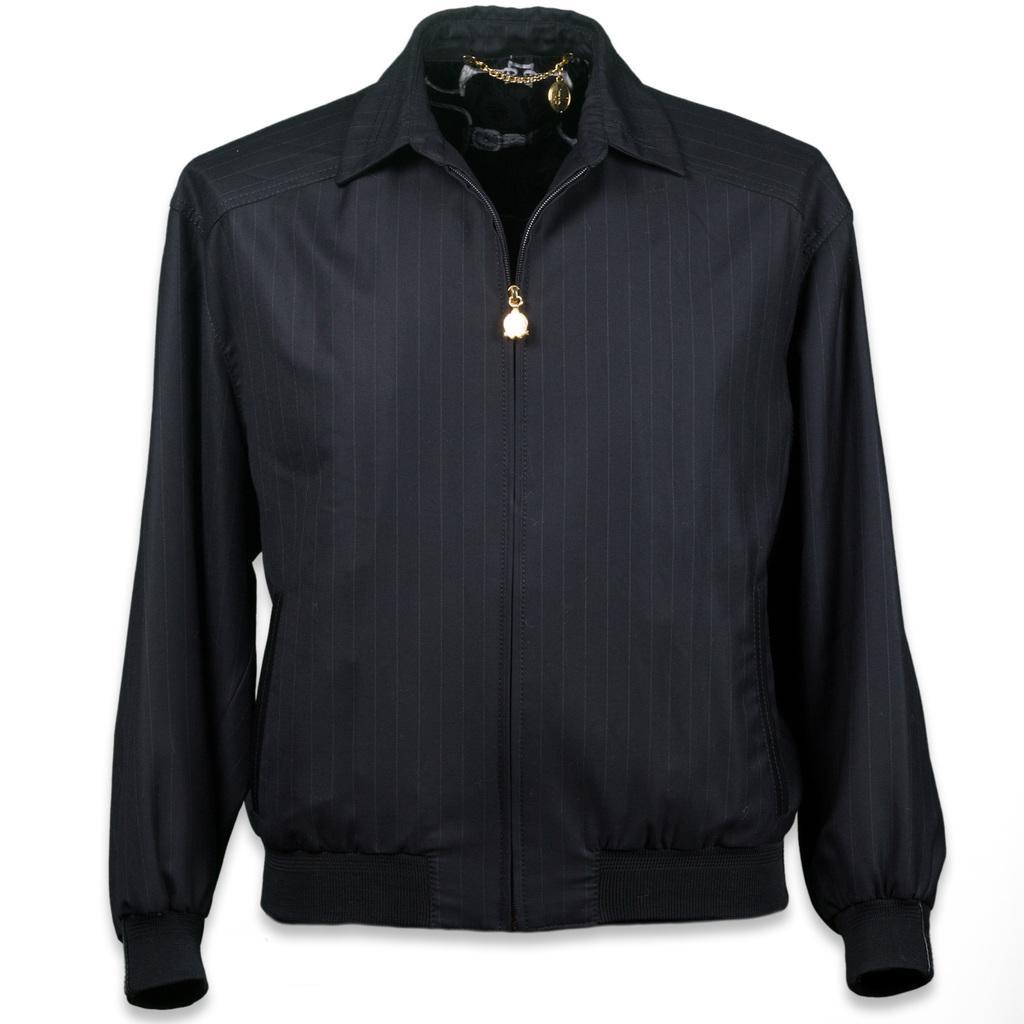Can you describe this image briefly? In this image I see a jacket which is of black in color and I see a chain over here which is of golden in color and it is white in the background. 